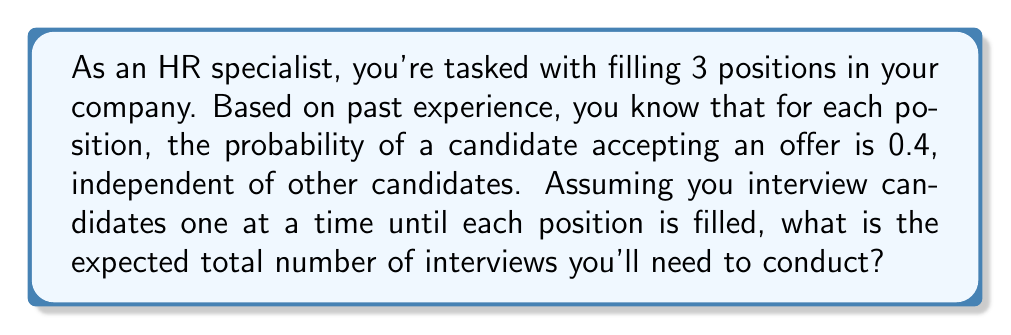Provide a solution to this math problem. Let's approach this step-by-step:

1) First, we need to recognize that this scenario follows a negative binomial distribution for each position. We're essentially asking how many trials (interviews) are needed until we get one success (acceptance).

2) For a single position, the expected number of trials until success in a negative binomial distribution is given by:

   $$E(X) = \frac{1}{p}$$

   where $p$ is the probability of success on each trial.

3) In this case, $p = 0.4$, so for a single position:

   $$E(X) = \frac{1}{0.4} = 2.5$$

4) Since we have 3 independent positions to fill, and the process for each is identical and independent, we can simply multiply this expectation by 3:

   $$E(\text{total interviews}) = 3 \cdot E(X) = 3 \cdot 2.5 = 7.5$$

5) Therefore, the expected total number of interviews needed to fill all 3 positions is 7.5.
Answer: 7.5 interviews 